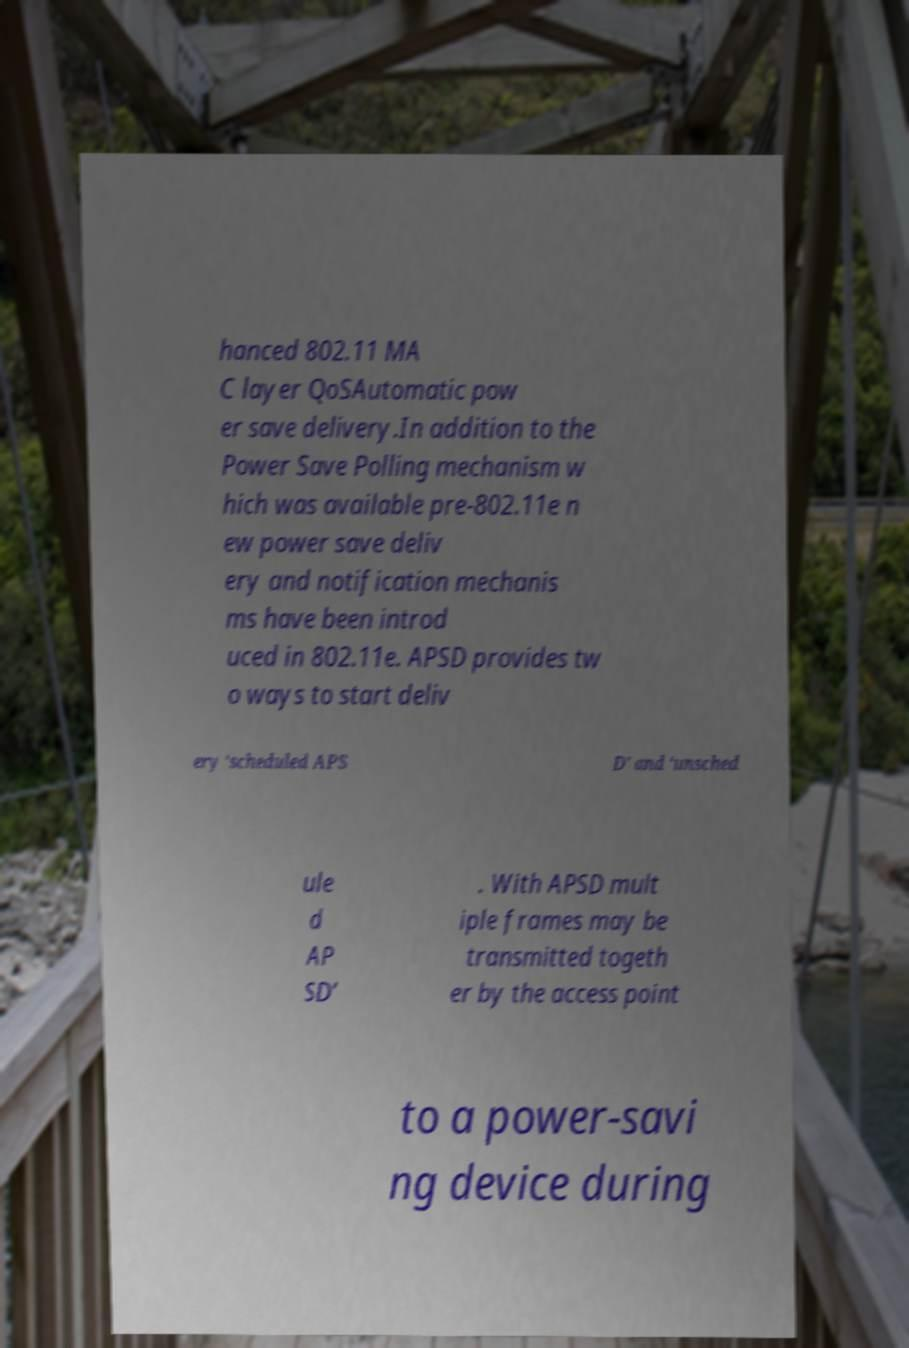Could you assist in decoding the text presented in this image and type it out clearly? hanced 802.11 MA C layer QoSAutomatic pow er save delivery.In addition to the Power Save Polling mechanism w hich was available pre-802.11e n ew power save deliv ery and notification mechanis ms have been introd uced in 802.11e. APSD provides tw o ways to start deliv ery ‘scheduled APS D’ and ‘unsched ule d AP SD’ . With APSD mult iple frames may be transmitted togeth er by the access point to a power-savi ng device during 